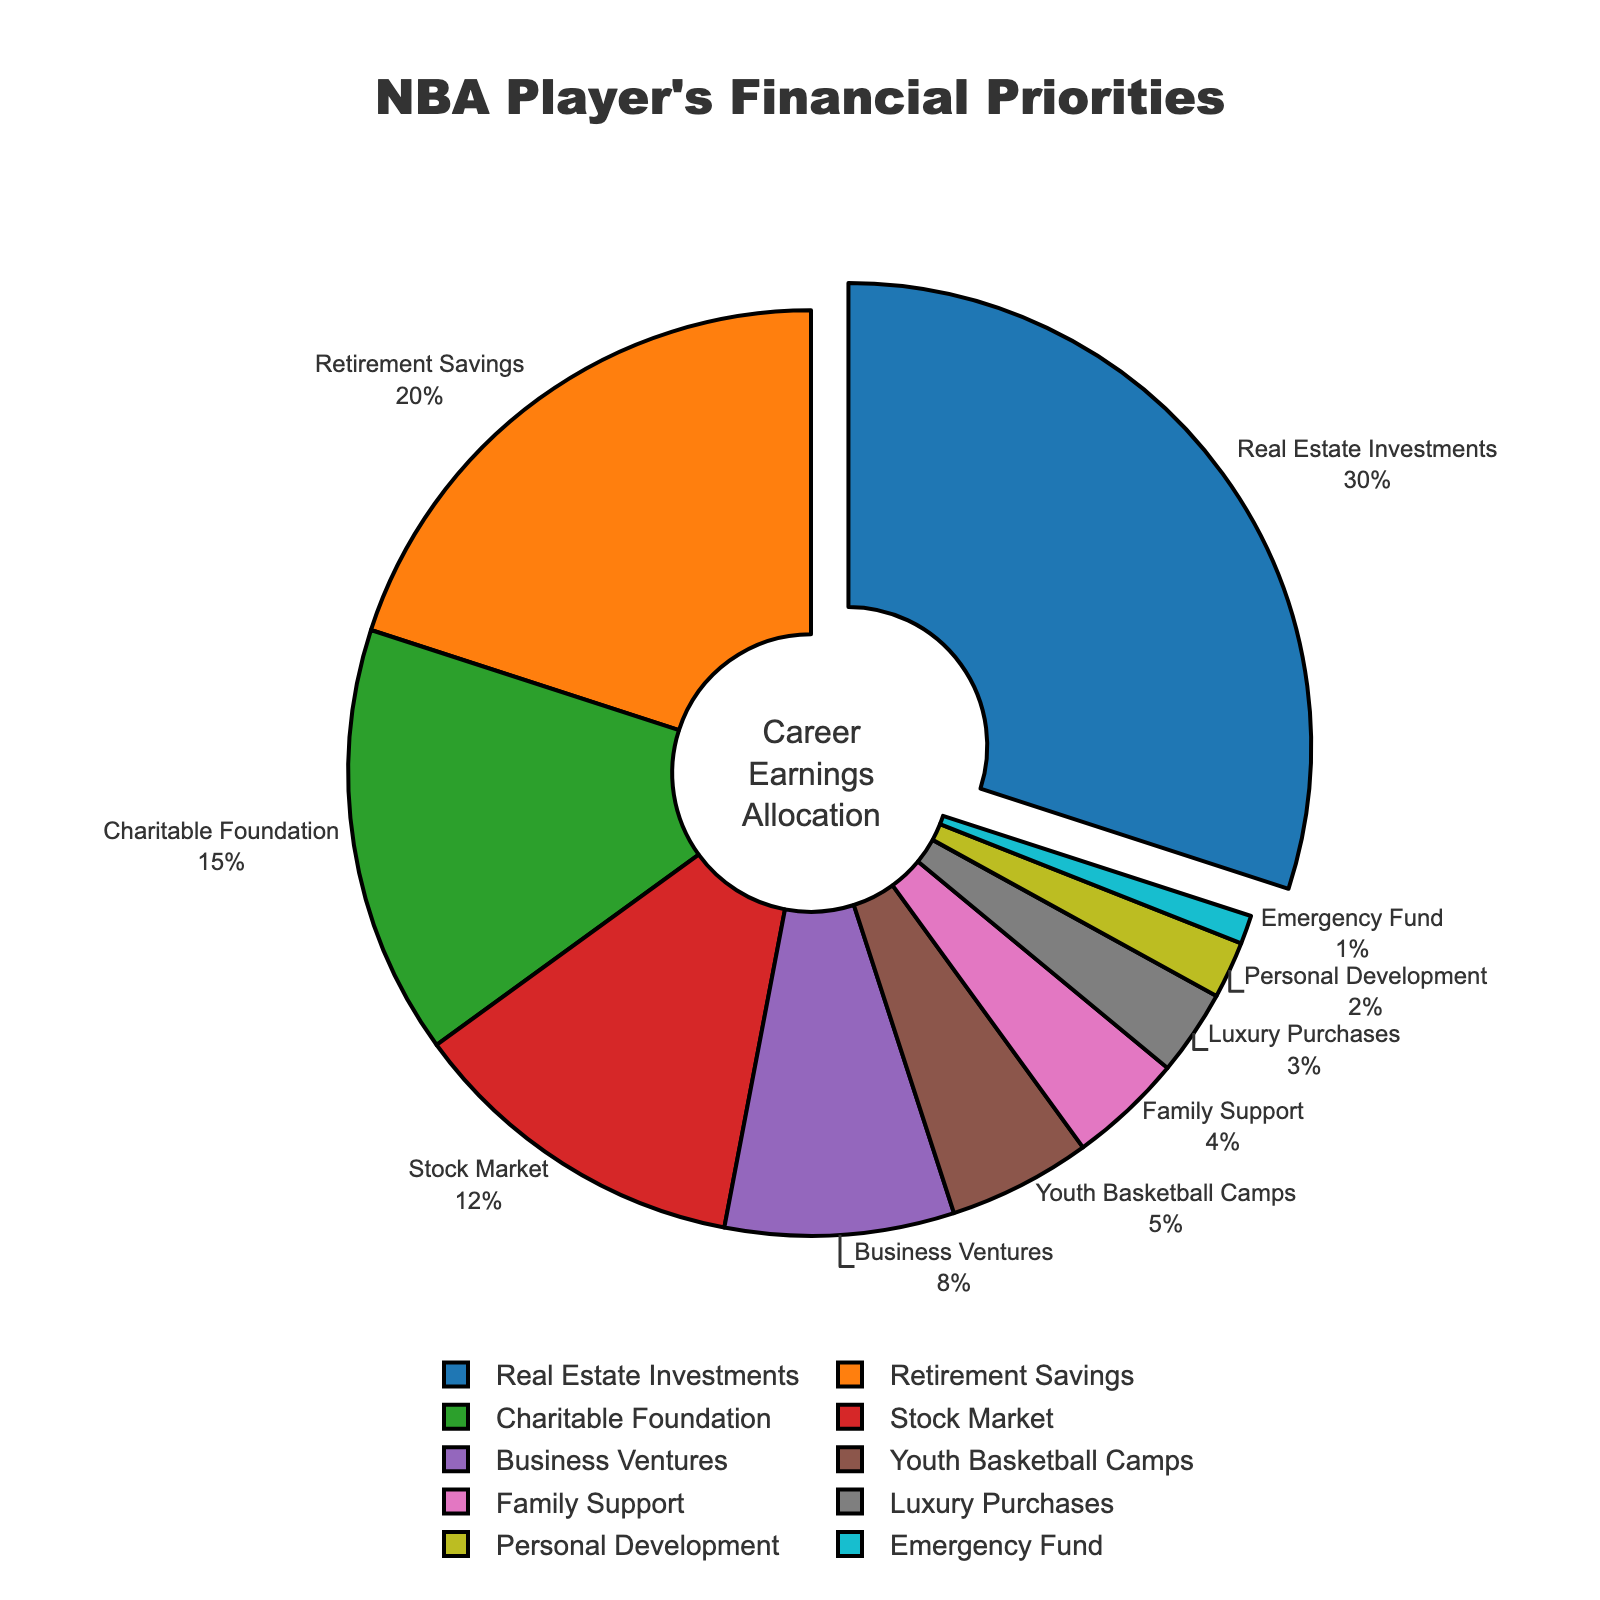What's the largest allocation category? The largest percentage is 30%, and it corresponds to Real Estate Investments.
Answer: Real Estate Investments How much more is allocated to Real Estate Investments compared to Business Ventures? Real Estate Investments is 30% and Business Ventures is 8%. The difference is 30 - 8 = 22%.
Answer: 22% Which categories together make up more than 50% of the allocations? Summing Real Estate Investments 30%, Retirement Savings 20%, and Charitable Foundation 15% gives 30 + 20 + 15 = 65%, which is more than 50%.
Answer: Real Estate Investments, Retirement Savings, Charitable Foundation What is the total percentage allocated to youth-related initiatives? Youth Basketball Camps and Charitable Foundation are considered youth-related. Summing 5% and 15% gives 5 + 15 = 20%.
Answer: 20% Compare the allocation to Family Support and Luxury Purchases. Which gets more and by how much? Family Support is 4% and Luxury Purchases is 3%. Family Support - Luxury Purchases = 4 - 3 = 1%.
Answer: Family Support by 1% Which category has the smallest allocation and what is it? The smallest percentage is 1% and it corresponds to Emergency Fund.
Answer: Emergency Fund What percentage of the total is allocated to Retirement Savings, Stock Market, and Business Ventures combined? Summing Retirement Savings 20%, Stock Market 12%, and Business Ventures 8% gives 20 + 12 + 8 = 40%.
Answer: 40% If the category with the smallest allocation doubled, what would its new percentage be and would it surpass any other category? Doubling Emergency Fund's 1% makes it 2%. It would then be equal to Personal Development, and still less than all other categories.
Answer: 2%, equal to Personal Development Identify the categories that get less than 10% allocation. Business Ventures 8%, Youth Basketball Camps 5%, Family Support 4%, Luxury Purchases 3%, Personal Development 2%, Emergency Fund 1%.
Answer: Business Ventures, Youth Basketball Camps, Family Support, Luxury Purchases, Personal Development, Emergency Fund 